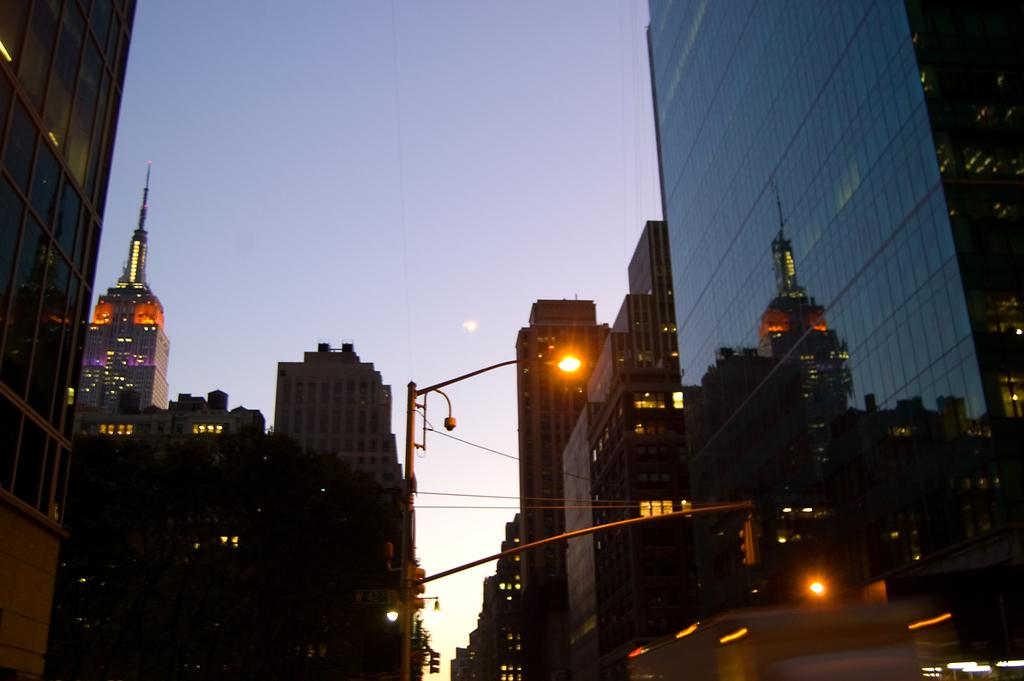What type of structures can be seen in the image? There are buildings in the image. What other objects are present in the image besides the buildings? There are light poles in the image. What can be seen in the background of the image? The sky is visible in the background of the image. Can you see a group of quills being used by a winged creature in the image? There is no winged creature or group of quills present in the image. 